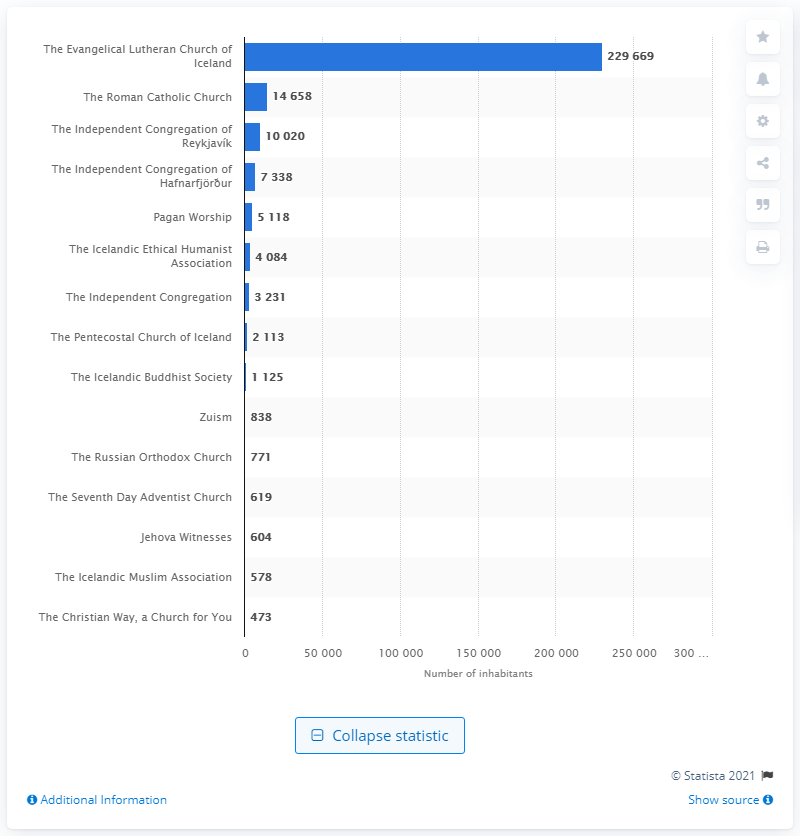Draw attention to some important aspects in this diagram. As of the start of 2021, the Icelandic Muslim Association had 578 members. As of 2021, the number of Roman Catholic Church members was approximately 1,465,800. In 2021, the Evangelical Lutheran Church of Iceland had a total of 229,669 members. 